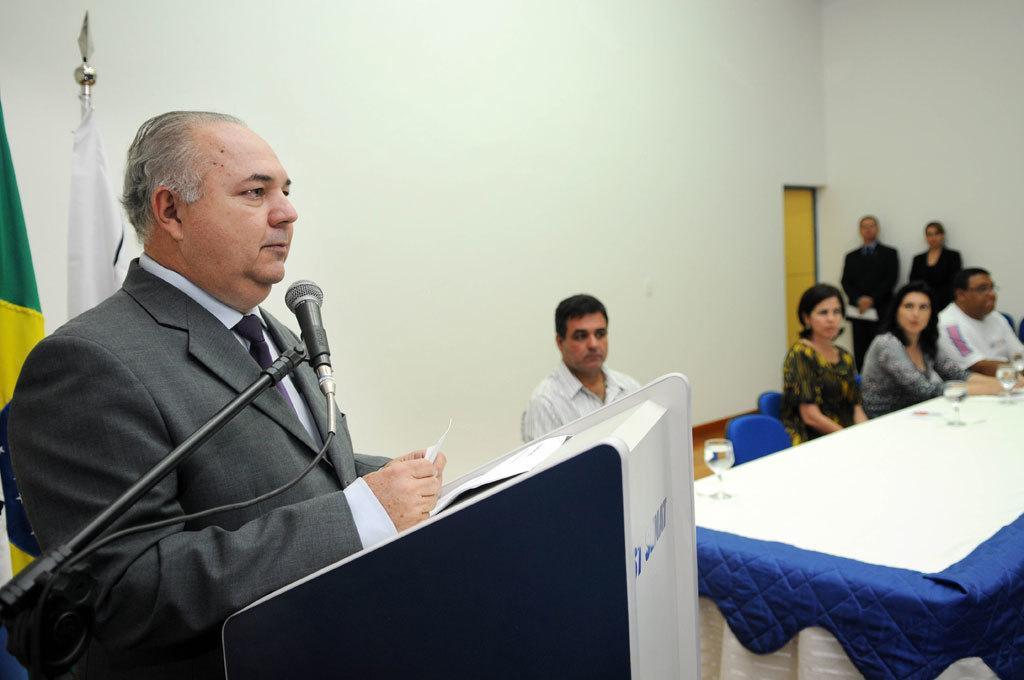Describe this image in one or two sentences. In this image we can see a person is standing in front of the podium, he is wearing grey color suit. In front of him one mic is there. To the right side of the image one table is there covered with white and blue color cloth, on table glasses are present. Behind table people are sitting on blue color chair. to the background of the image two persons are standing. To the left side of the image we can see flags are there. 